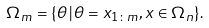Convert formula to latex. <formula><loc_0><loc_0><loc_500><loc_500>\Omega _ { m } = \{ \theta \, | \, \theta = x _ { 1 \colon m } , x \in \Omega _ { n } \} .</formula> 